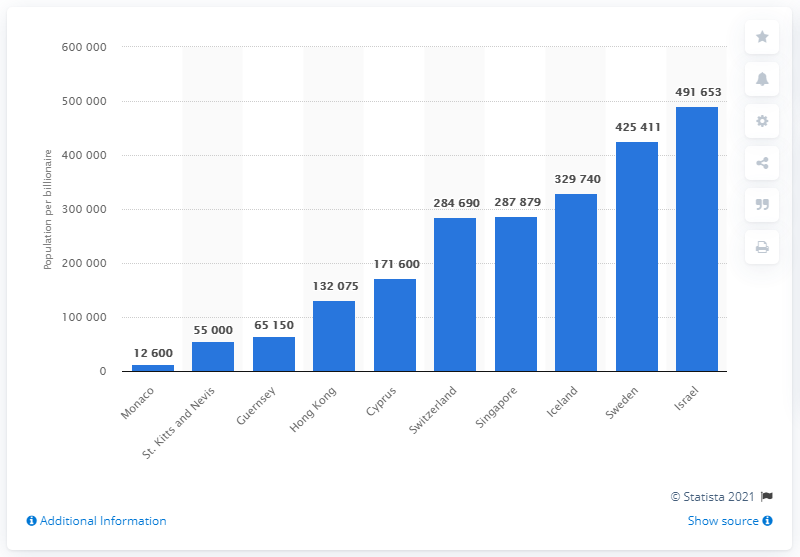Draw attention to some important aspects in this diagram. In 2015, Monaco had the highest number of billionaires per capita among all countries. 